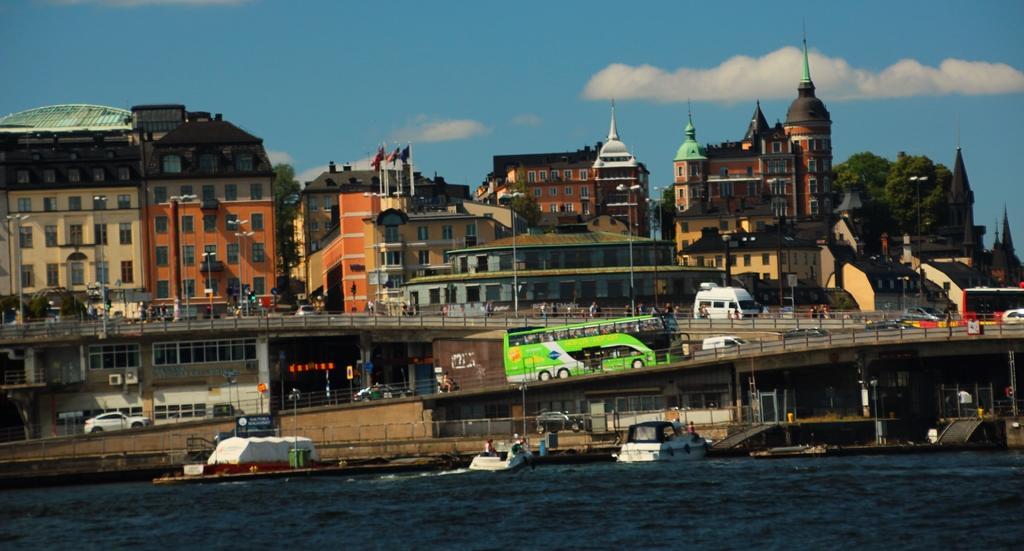Can you describe this image briefly? In this image we can see water on which there are some boats and there are some vehicles moving on road and in the background of the image there are some buildings, some trees and clear sky. 